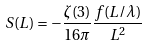<formula> <loc_0><loc_0><loc_500><loc_500>S ( L ) = - \frac { \zeta ( 3 ) } { 1 6 \pi } \frac { f ( L / \lambda ) } { L ^ { 2 } }</formula> 